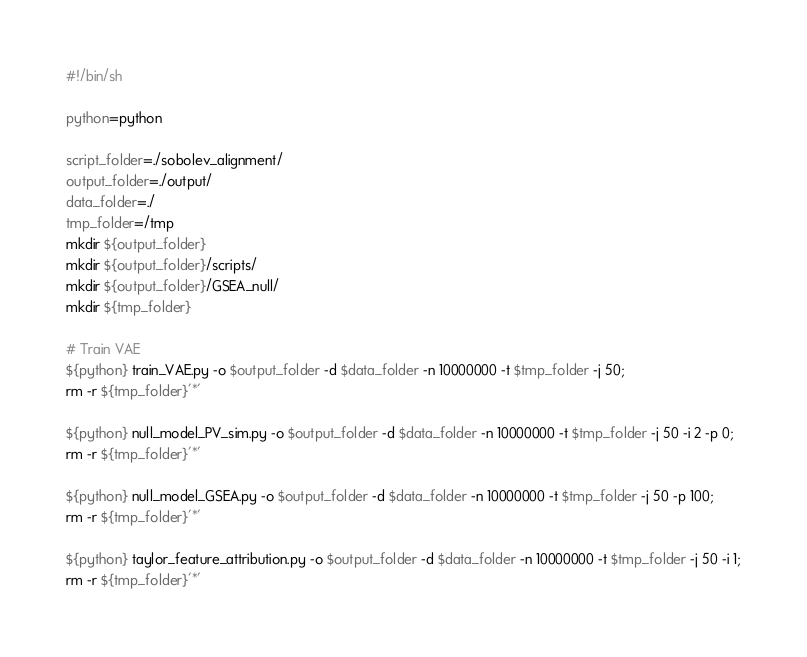<code> <loc_0><loc_0><loc_500><loc_500><_Bash_>#!/bin/sh

python=python

script_folder=./sobolev_alignment/
output_folder=./output/
data_folder=./
tmp_folder=/tmp
mkdir ${output_folder}
mkdir ${output_folder}/scripts/
mkdir ${output_folder}/GSEA_null/
mkdir ${tmp_folder}

# Train VAE
${python} train_VAE.py -o $output_folder -d $data_folder -n 10000000 -t $tmp_folder -j 50;
rm -r ${tmp_folder}'*'

${python} null_model_PV_sim.py -o $output_folder -d $data_folder -n 10000000 -t $tmp_folder -j 50 -i 2 -p 0;
rm -r ${tmp_folder}'*'

${python} null_model_GSEA.py -o $output_folder -d $data_folder -n 10000000 -t $tmp_folder -j 50 -p 100;
rm -r ${tmp_folder}'*'

${python} taylor_feature_attribution.py -o $output_folder -d $data_folder -n 10000000 -t $tmp_folder -j 50 -i 1;
rm -r ${tmp_folder}'*'</code> 